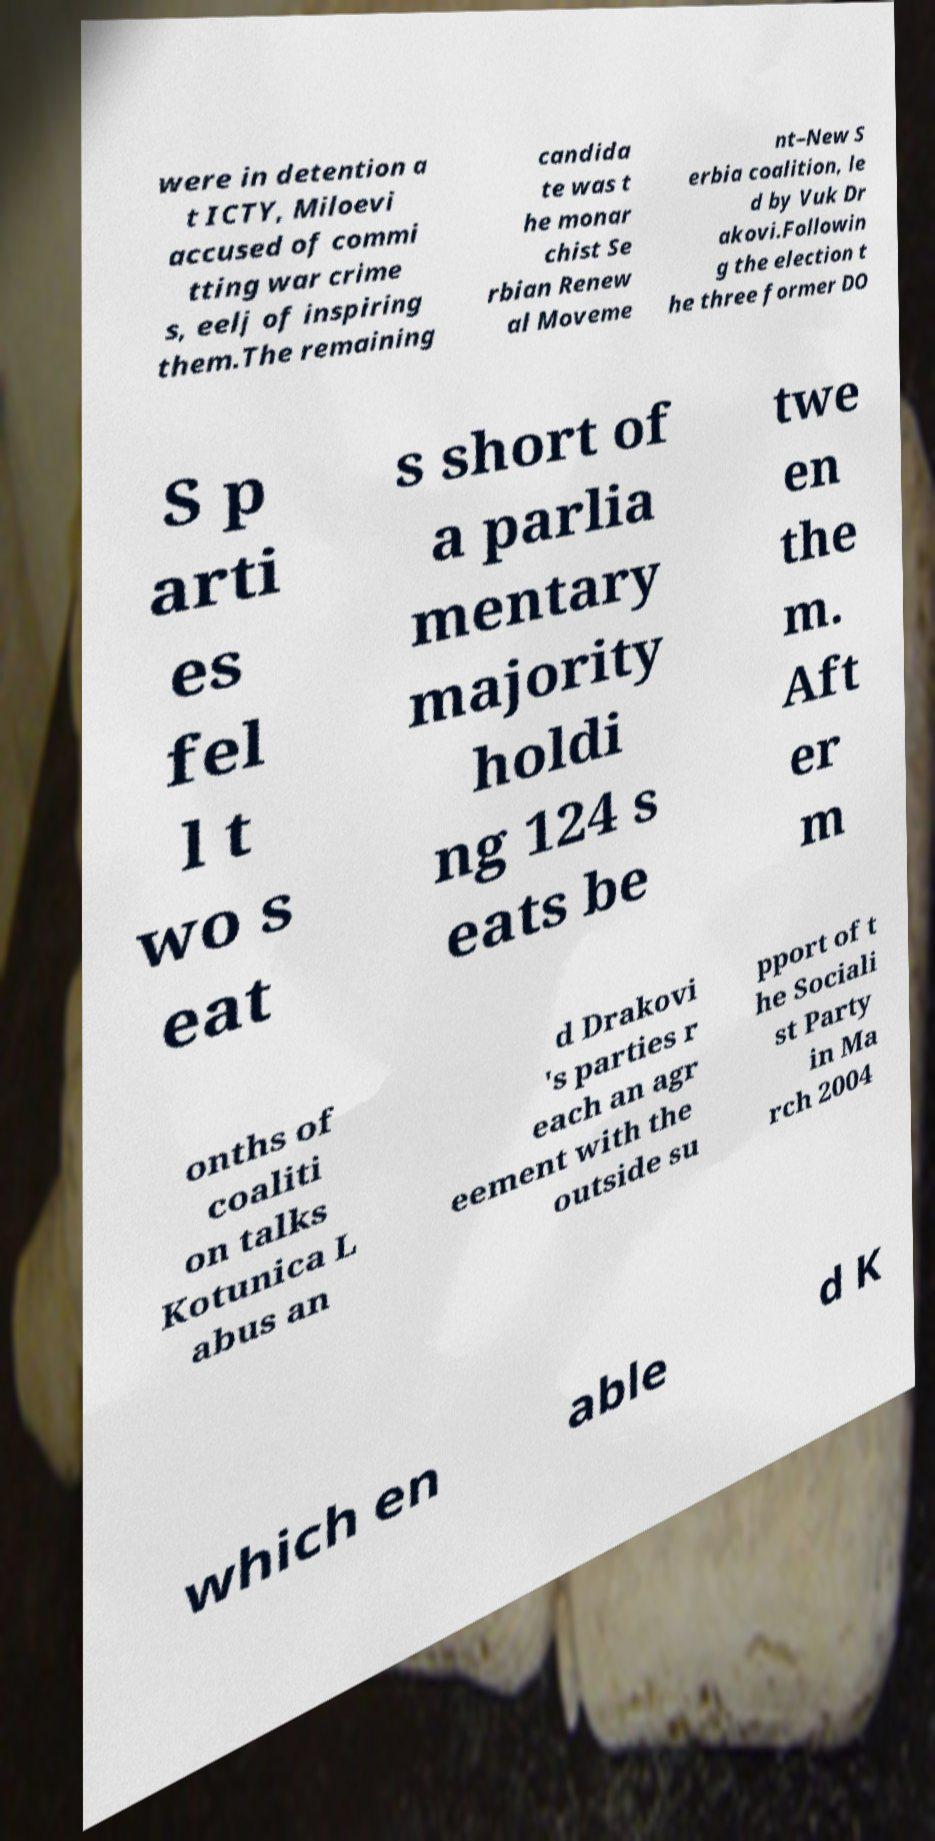Could you extract and type out the text from this image? were in detention a t ICTY, Miloevi accused of commi tting war crime s, eelj of inspiring them.The remaining candida te was t he monar chist Se rbian Renew al Moveme nt–New S erbia coalition, le d by Vuk Dr akovi.Followin g the election t he three former DO S p arti es fel l t wo s eat s short of a parlia mentary majority holdi ng 124 s eats be twe en the m. Aft er m onths of coaliti on talks Kotunica L abus an d Drakovi 's parties r each an agr eement with the outside su pport of t he Sociali st Party in Ma rch 2004 which en able d K 